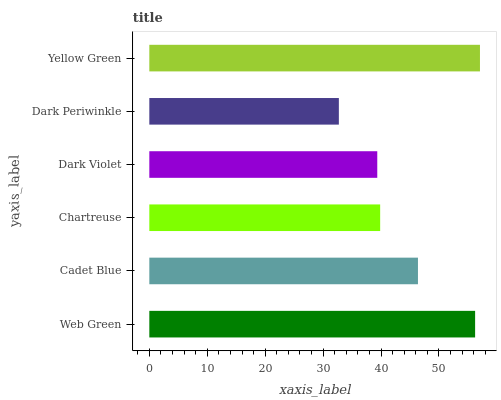Is Dark Periwinkle the minimum?
Answer yes or no. Yes. Is Yellow Green the maximum?
Answer yes or no. Yes. Is Cadet Blue the minimum?
Answer yes or no. No. Is Cadet Blue the maximum?
Answer yes or no. No. Is Web Green greater than Cadet Blue?
Answer yes or no. Yes. Is Cadet Blue less than Web Green?
Answer yes or no. Yes. Is Cadet Blue greater than Web Green?
Answer yes or no. No. Is Web Green less than Cadet Blue?
Answer yes or no. No. Is Cadet Blue the high median?
Answer yes or no. Yes. Is Chartreuse the low median?
Answer yes or no. Yes. Is Web Green the high median?
Answer yes or no. No. Is Yellow Green the low median?
Answer yes or no. No. 